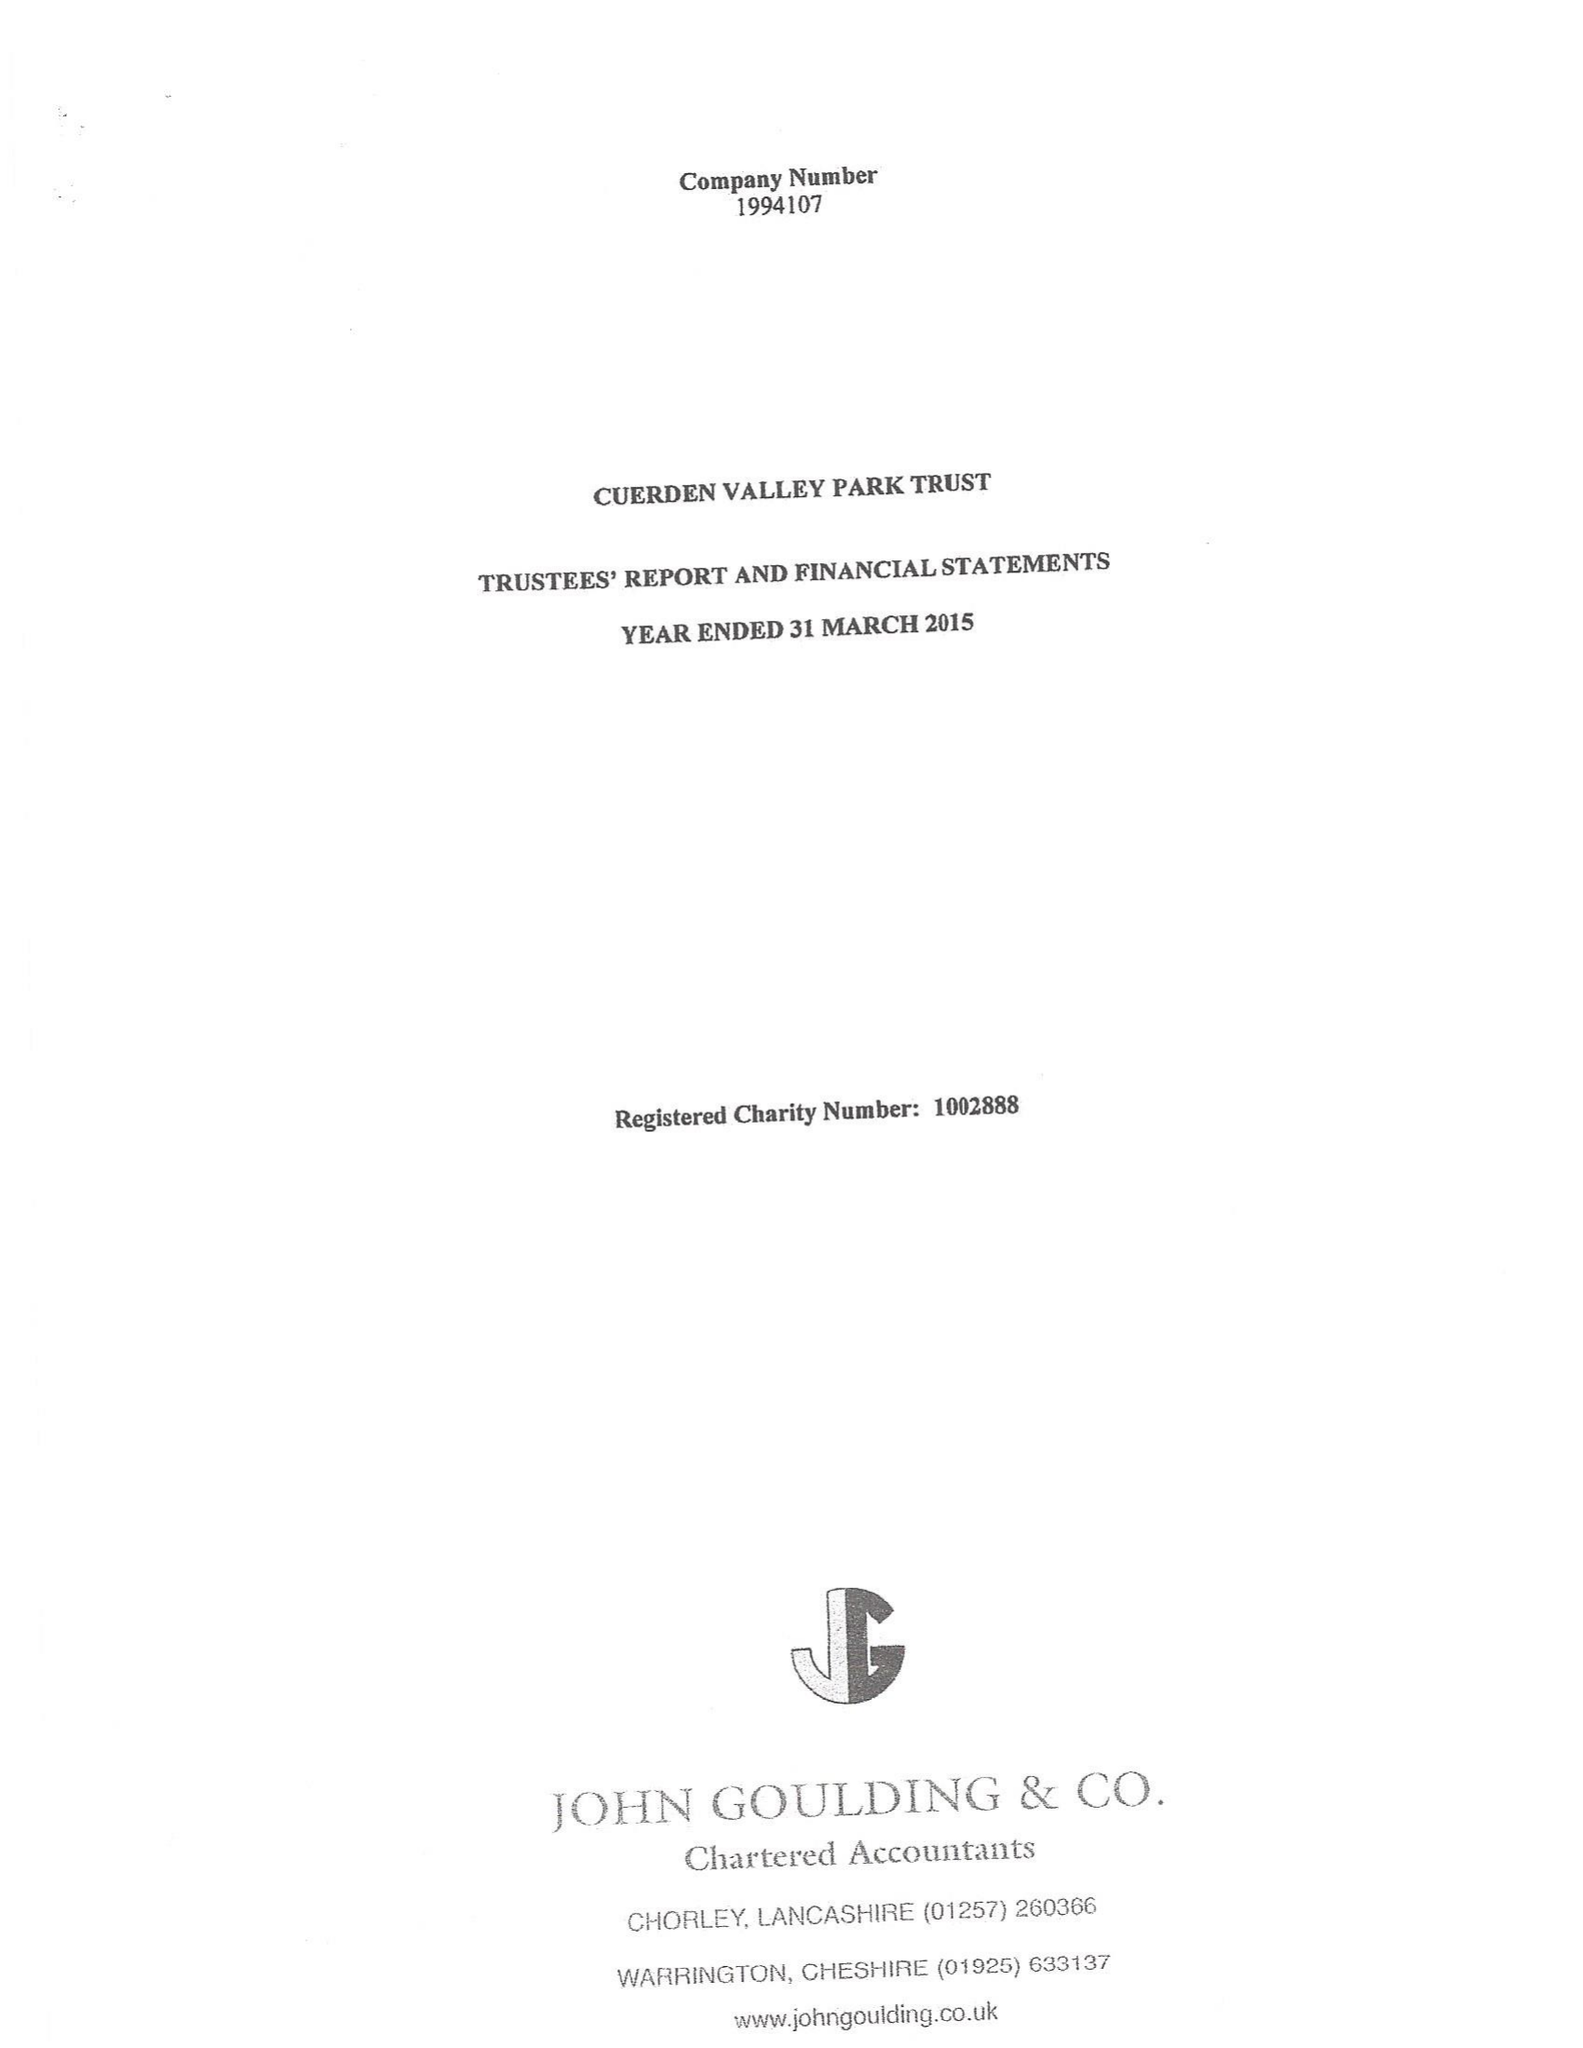What is the value for the income_annually_in_british_pounds?
Answer the question using a single word or phrase. 283709.00 